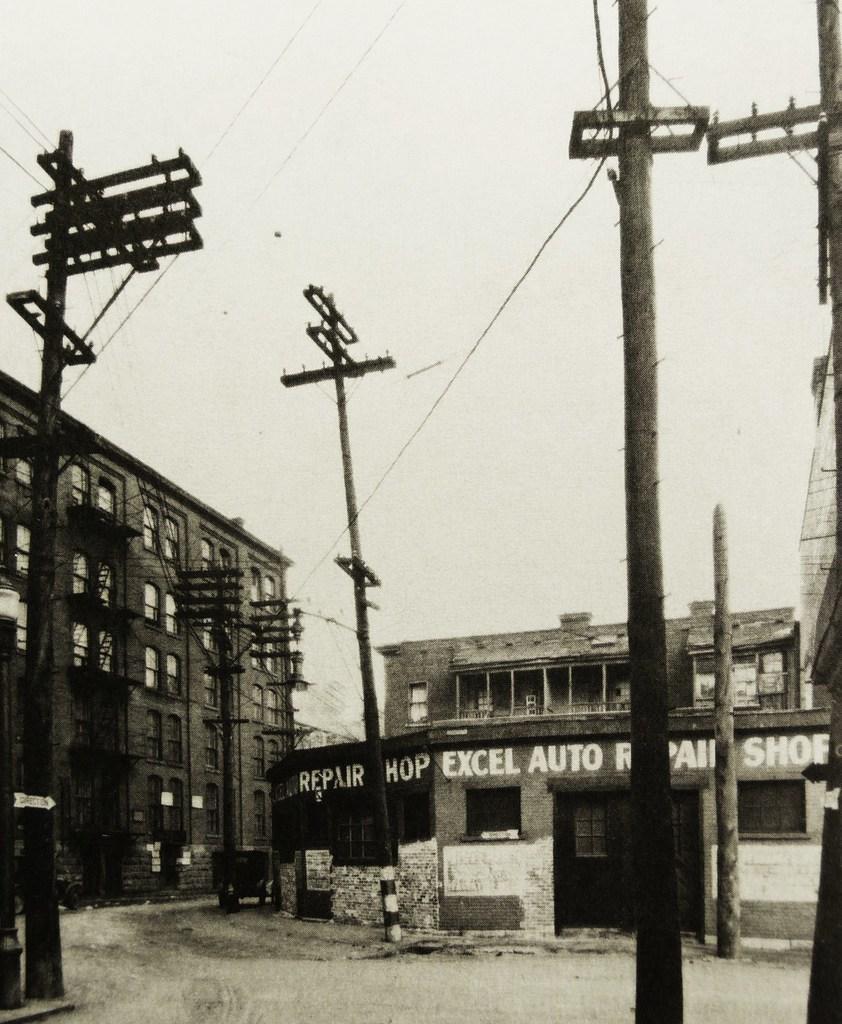Could you give a brief overview of what you see in this image? This is a black and white image in this image there are electrical poles, and there are buildings in one of the building there is a text. 